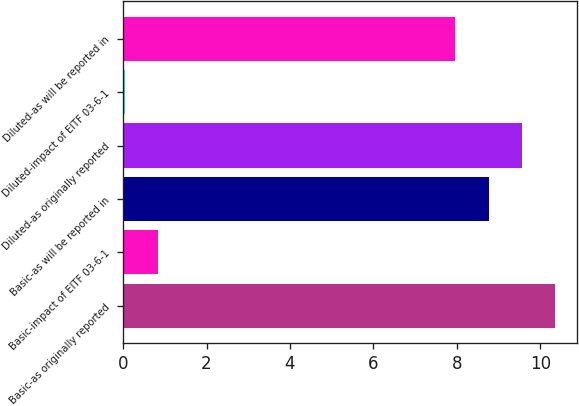Convert chart. <chart><loc_0><loc_0><loc_500><loc_500><bar_chart><fcel>Basic-as originally reported<fcel>Basic-impact of EITF 03-6-1<fcel>Basic-as will be reported in<fcel>Diluted-as originally reported<fcel>Diluted-impact of EITF 03-6-1<fcel>Diluted-as will be reported in<nl><fcel>10.36<fcel>0.84<fcel>8.76<fcel>9.56<fcel>0.04<fcel>7.96<nl></chart> 